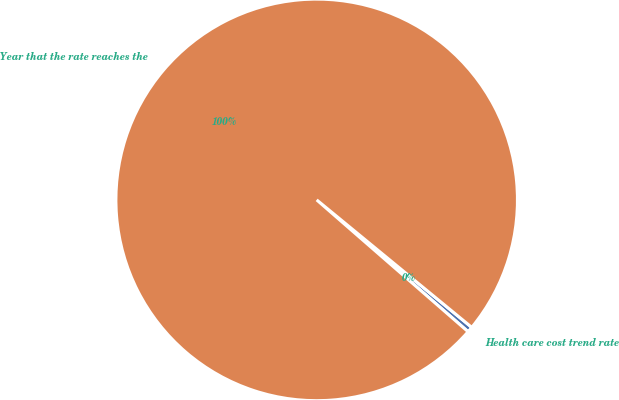Convert chart. <chart><loc_0><loc_0><loc_500><loc_500><pie_chart><fcel>Health care cost trend rate<fcel>Year that the rate reaches the<nl><fcel>0.45%<fcel>99.55%<nl></chart> 